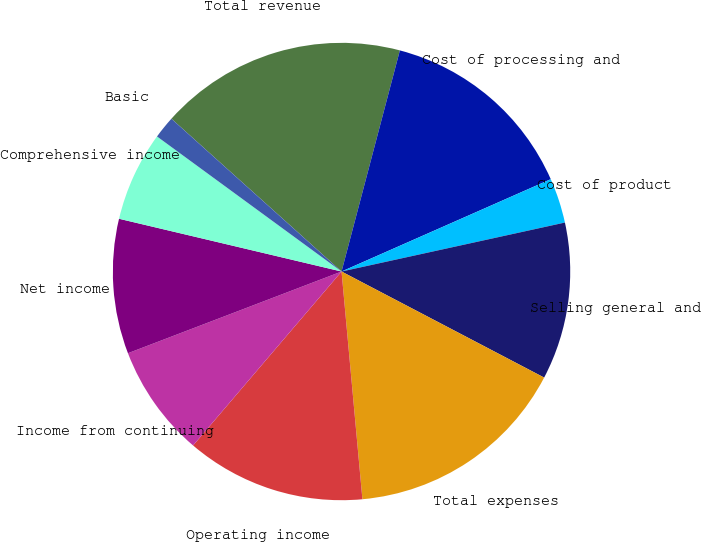<chart> <loc_0><loc_0><loc_500><loc_500><pie_chart><fcel>Total revenue<fcel>Cost of processing and<fcel>Cost of product<fcel>Selling general and<fcel>Total expenses<fcel>Operating income<fcel>Income from continuing<fcel>Net income<fcel>Comprehensive income<fcel>Basic<nl><fcel>17.46%<fcel>14.28%<fcel>3.18%<fcel>11.11%<fcel>15.87%<fcel>12.7%<fcel>7.94%<fcel>9.52%<fcel>6.35%<fcel>1.59%<nl></chart> 